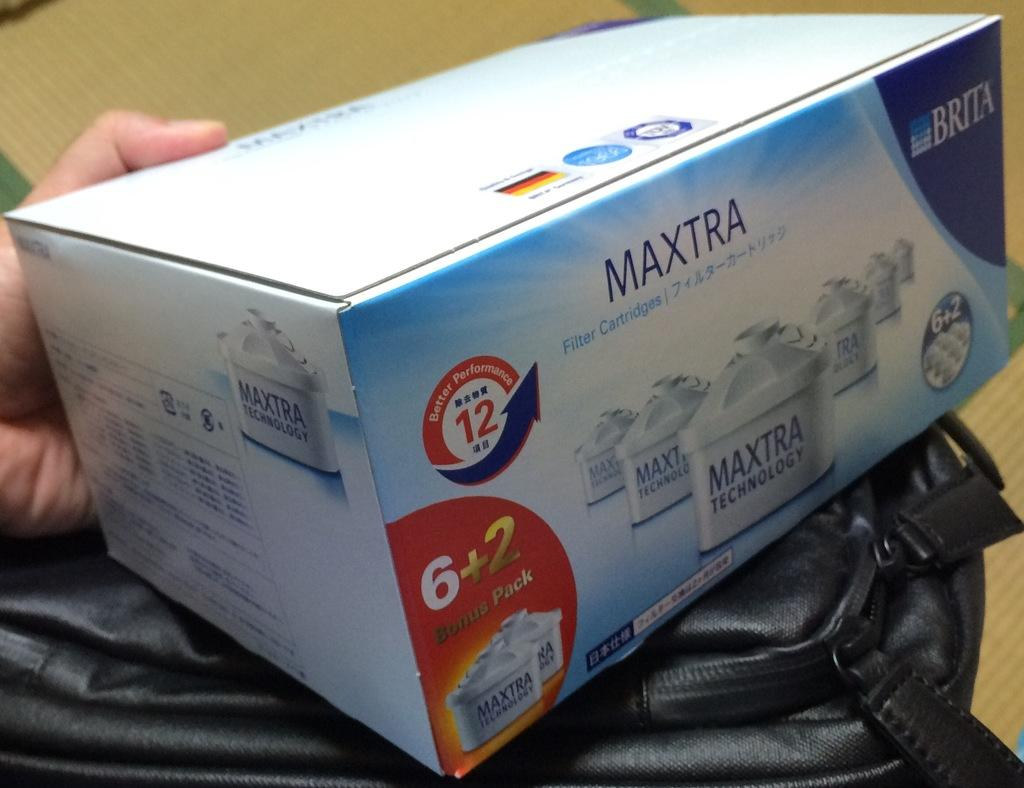<image>
Render a clear and concise summary of the photo. Someone holds a box of Mextra Brita Filter Cartridges. 